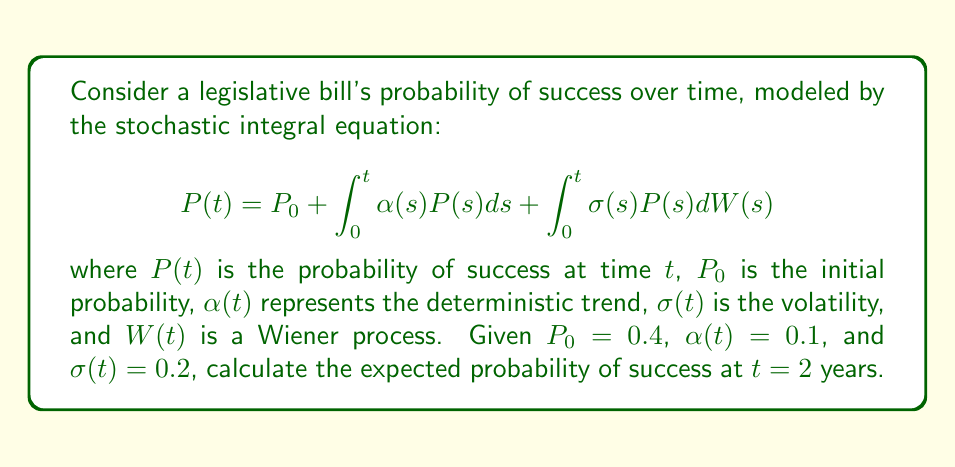Can you answer this question? To solve this problem, we need to follow these steps:

1) The given equation is a linear stochastic differential equation (SDE) of the form:

   $$dP(t) = \alpha(t)P(t)dt + \sigma(t)P(t)dW(t)$$

2) For this type of SDE, we can use Itô's formula to find the solution. The general solution is:

   $$P(t) = P_0 \exp\left(\int_0^t (\alpha(s) - \frac{1}{2}\sigma^2(s))ds + \int_0^t \sigma(s)dW(s)\right)$$

3) In our case, $\alpha(t)$ and $\sigma(t)$ are constant, so we can simplify:

   $$P(t) = P_0 \exp\left((\alpha - \frac{1}{2}\sigma^2)t + \sigma W(t)\right)$$

4) To find the expected value, we use the property $E[e^{aW(t)}] = e^{\frac{1}{2}a^2t}$:

   $$E[P(t)] = P_0 \exp\left((\alpha - \frac{1}{2}\sigma^2)t + \frac{1}{2}\sigma^2t\right) = P_0 e^{\alpha t}$$

5) Substituting the given values:

   $$E[P(2)] = 0.4 e^{0.1 \cdot 2} = 0.4 e^{0.2} \approx 0.4889$$

Thus, the expected probability of success after 2 years is approximately 0.4889 or 48.89%.
Answer: 0.4889 